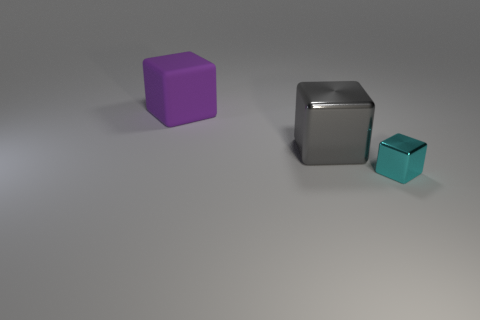What number of objects are big things in front of the big rubber cube or shiny blocks behind the small metal thing?
Offer a very short reply. 1. There is a object that is both behind the small cyan metal object and on the right side of the purple rubber thing; what is its size?
Provide a short and direct response. Large. There is a big object that is in front of the large purple rubber cube; is its shape the same as the purple matte object?
Make the answer very short. Yes. What size is the block to the right of the metal object that is on the left side of the metallic cube to the right of the gray shiny object?
Keep it short and to the point. Small. How many things are either small purple metallic spheres or purple blocks?
Your answer should be very brief. 1. What is the shape of the object that is both left of the tiny cyan block and right of the purple matte object?
Provide a short and direct response. Cube. There is a large metallic object; is it the same shape as the object that is right of the gray block?
Ensure brevity in your answer.  Yes. Are there any big purple matte blocks to the right of the rubber block?
Offer a very short reply. No. How many cubes are tiny cyan matte things or cyan objects?
Provide a short and direct response. 1. Do the large purple thing and the gray shiny thing have the same shape?
Offer a terse response. Yes. 